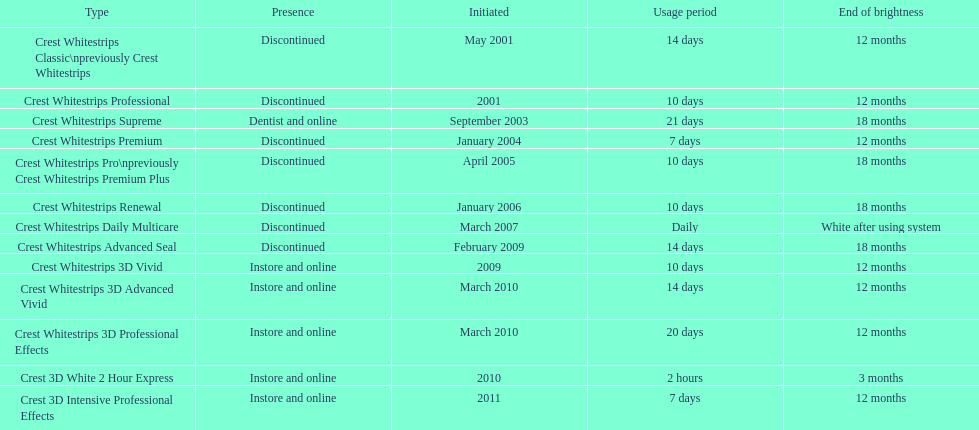What product was introduced in the same month as crest whitestrips 3d advanced vivid? Crest Whitestrips 3D Professional Effects. 